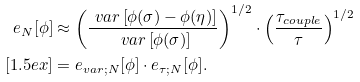Convert formula to latex. <formula><loc_0><loc_0><loc_500><loc_500>e _ { N } [ \phi ] & \approx \left ( \frac { \ v a r \left [ \phi ( \sigma ) - \phi ( \eta ) \right ] } { \ v a r \left [ \phi ( \sigma ) \right ] } \right ) ^ { 1 / 2 } \cdot \left ( \frac { \tau _ { c o u p l e } } { \tau } \right ) ^ { 1 / 2 } \\ [ 1 . 5 e x ] & = e _ { v a r ; N } [ \phi ] \cdot e _ { \tau ; N } [ \phi ] .</formula> 